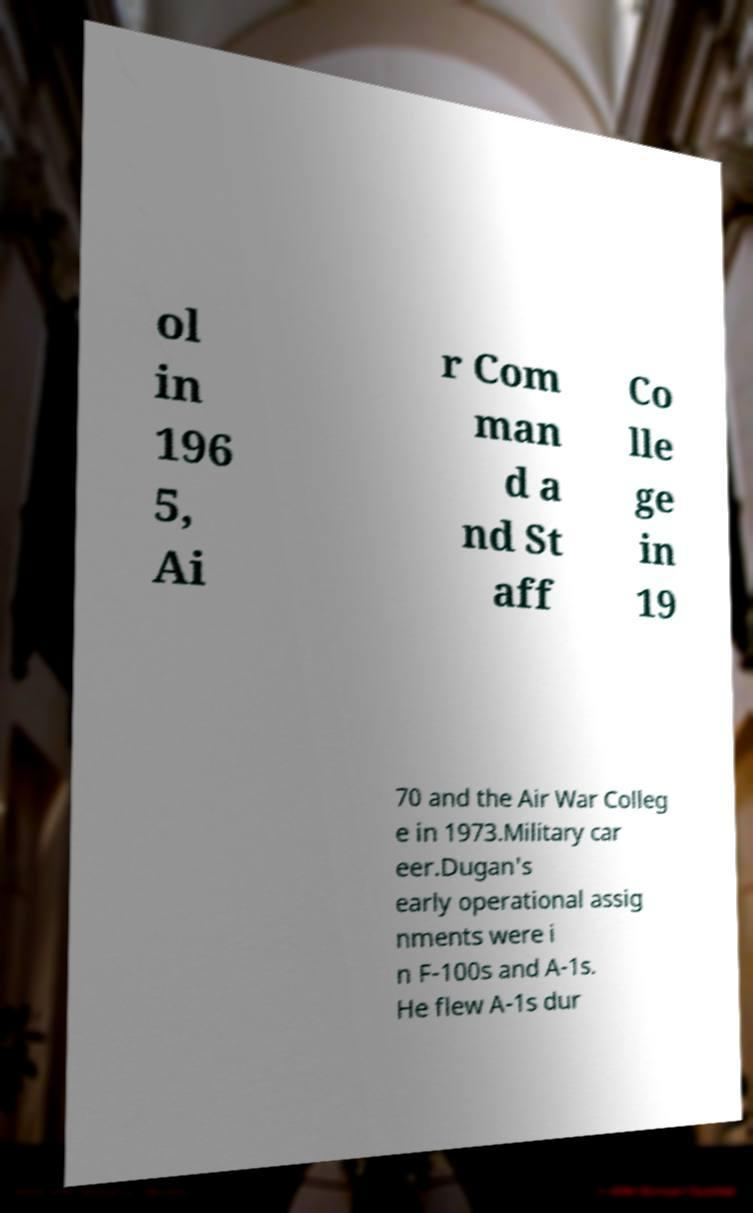Please read and relay the text visible in this image. What does it say? ol in 196 5, Ai r Com man d a nd St aff Co lle ge in 19 70 and the Air War Colleg e in 1973.Military car eer.Dugan's early operational assig nments were i n F-100s and A-1s. He flew A-1s dur 